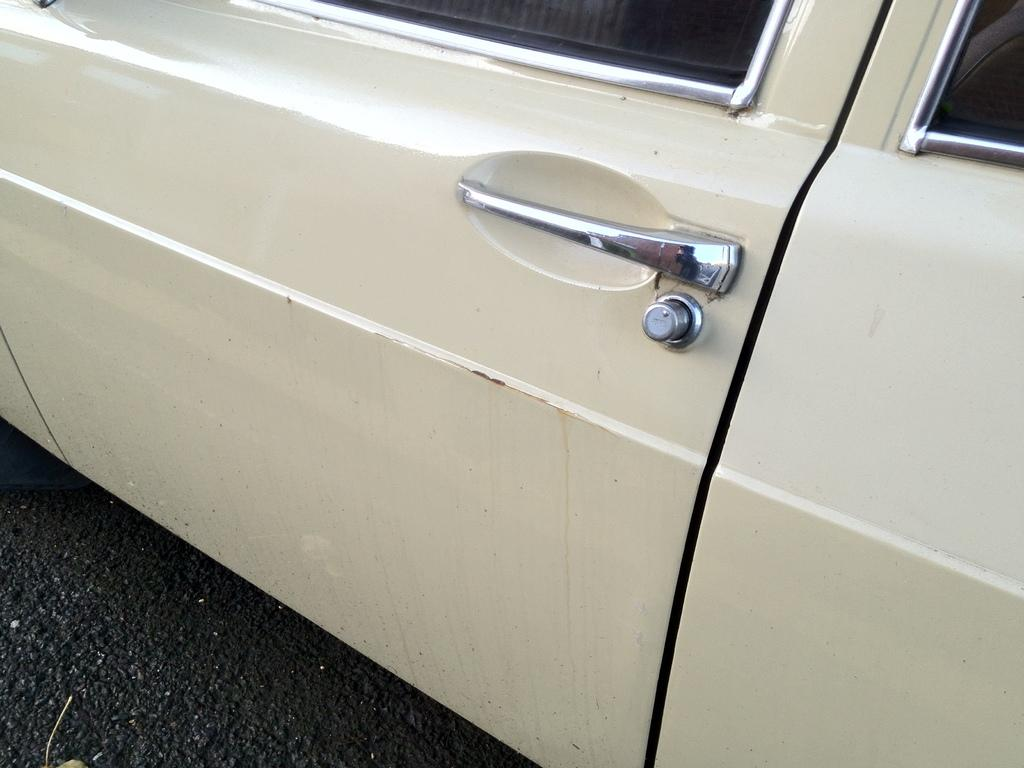What is the main subject of the picture? The main subject of the picture is a vehicle. What features can be seen on the vehicle? There is a window and a door in the vehicle. Is there any part of the vehicle that can be used to open or close it? Yes, there is a handle in the vehicle. What type of holiday is being celebrated in the vehicle? There is no indication of a holiday being celebrated in the vehicle, as the image only shows a vehicle with a window, door, and handle. What are the hopes of the sand in the vehicle? There is no sand present in the vehicle, so it is not possible to determine the hopes of any sand. 